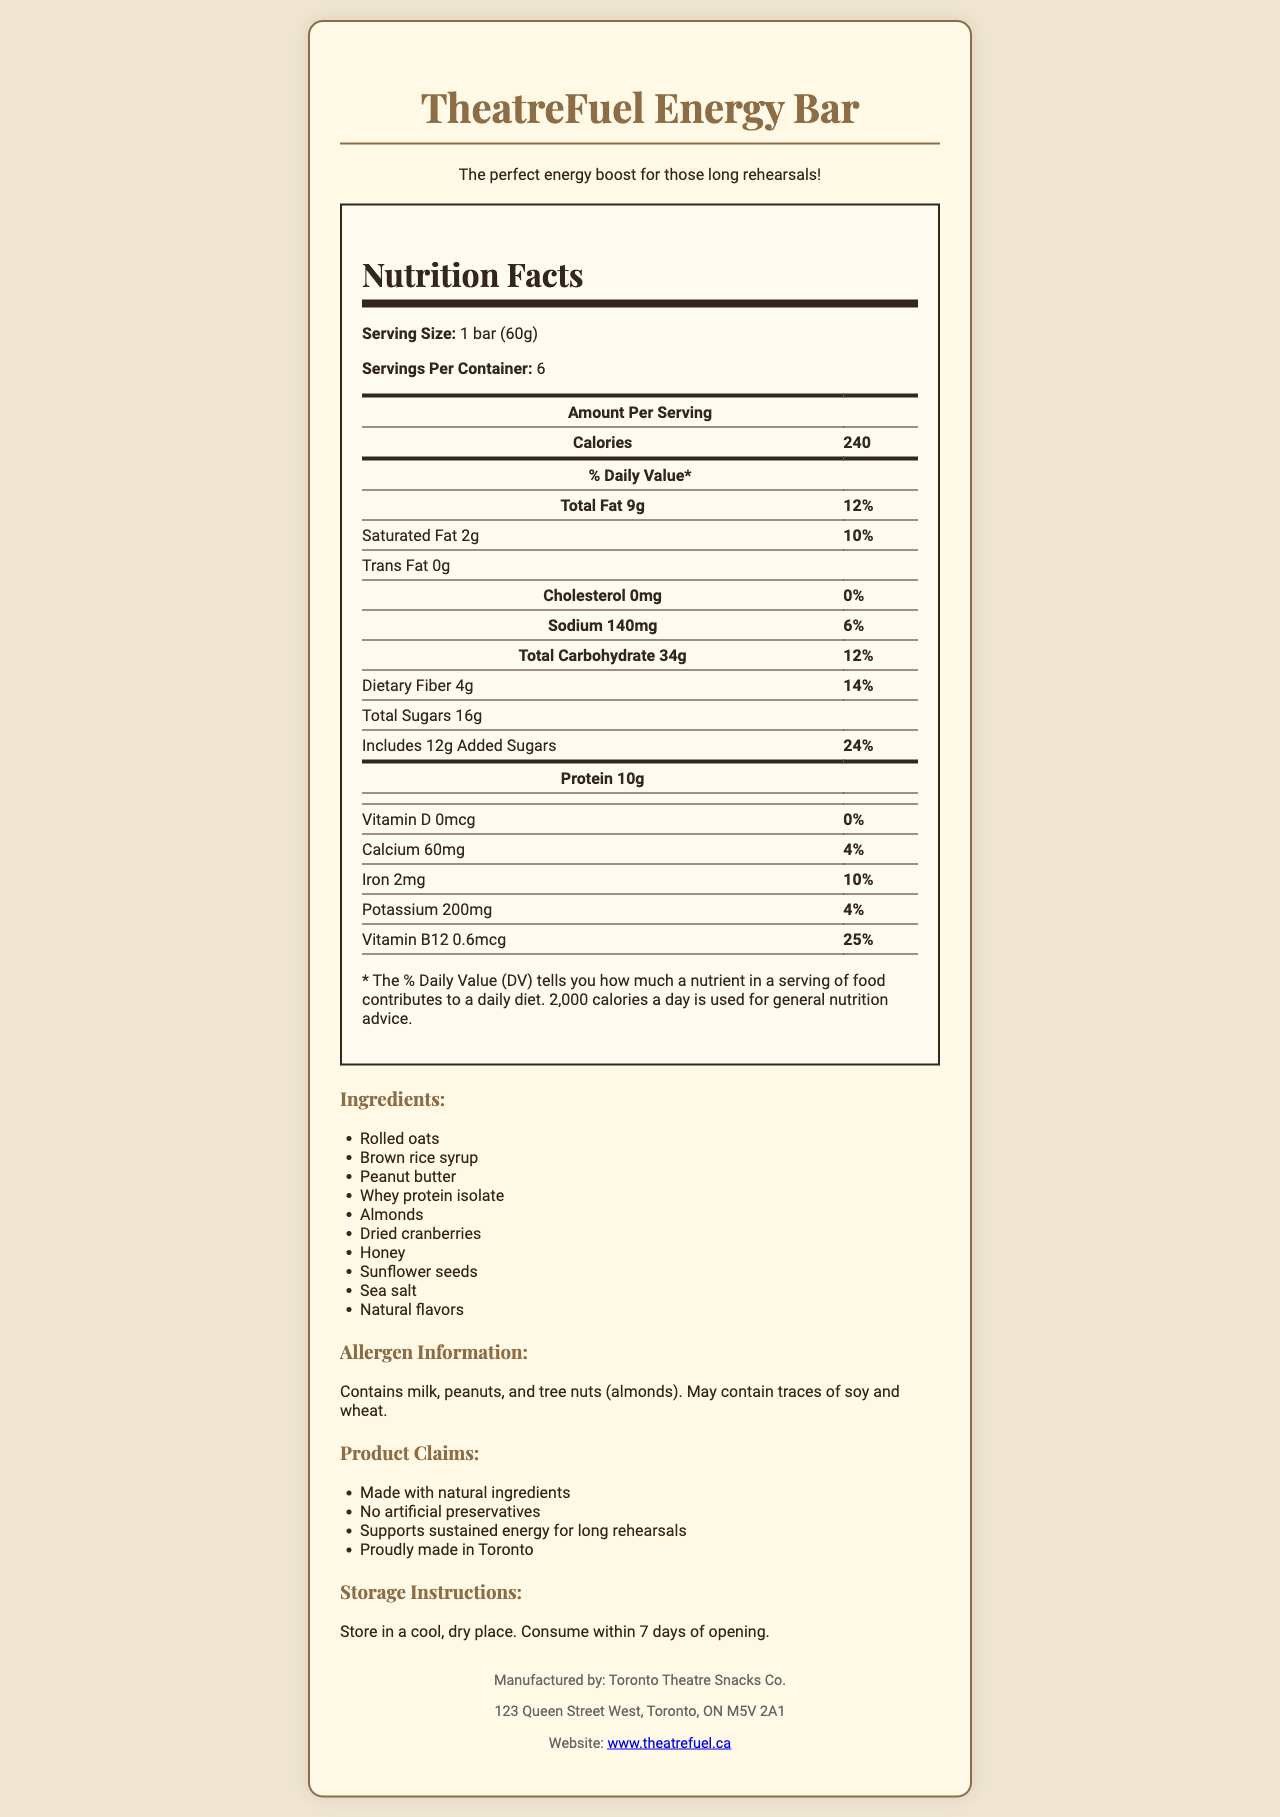what is the serving size of TheatreFuel Energy Bar? The serving size is clearly mentioned below the product name in the nutrition facts section as "1 bar (60g)".
Answer: 1 bar (60g) how many servings are in one container? The document states that there are 6 servings per container.
Answer: 6 how many calories are there per serving? The calories per serving are listed in the "Amount Per Serving" section as 240.
Answer: 240 what is the total fat content and its percentage of daily value? The "Total Fat" content is detailed with its amount as 9g and its daily value percentage as 12%.
Answer: 9g, 12% how much protein does each bar contain? The protein content per serving is listed as 10g.
Answer: 10g which ingredient might cause allergies? A. Rolled oats B. Peanut butter C. Sunflower seeds D. Honey The allergen information indicates that the product contains milk, peanuts (from peanut butter), and tree nuts.
Answer: B how should this product be stored for best results? The storage instructions indicate to store the product in a cool, dry place and to consume it within 7 days of opening.
Answer: Store in a cool, dry place. Consume within 7 days of opening. does the TheatreFuel Energy Bar contain any artificial preservatives? One of the product claims explicitly states "No artificial preservatives".
Answer: No how much dietary fiber is in one serving, and what percentage of the daily value does it provide? The dietary fiber content is 4g per serving, and it provides 14% of the daily value.
Answer: 4g, 14% how can you contact the manufacturer of TheatreFuel Energy Bar? The address of the manufacturer, Toronto Theatre Snacks Co., is provided at the bottom of the document.
Answer: 123 Queen Street West, Toronto, ON M5V 2A1 how much vitamin B12 is there per serving, and what percentage of the daily value does it provide? Vitamin B12 content per serving is 0.6mcg and it provides 25% of the daily value.
Answer: 0.6mcg, 25% are there any trans fats in this energy bar? The nutrition facts state that there is 0g of trans fat in the product.
Answer: No which of the following is a claim made about this product? A. Gluten-free B. Organic C. Supports sustained energy D. Low sodium Among the product claims, one claim is "Supports sustained energy for long rehearsals."
Answer: C what is the main idea of this document? The document comprehensively describe the nutritional facts, ingredients, allergen information, and claims about the TheatreFuel Energy Bar, intended to inform consumers about its contents and benefits.
Answer: The document provides detailed nutritional information about the TheatreFuel Energy Bar, including serving size, ingredients, allergen information, and storage instructions, along with claims about its benefits and manufacturing details. what is the fiber content of the product? A. 2g B. 4g C. 6g D. 8g The dietary fiber content is listed as 4g per serving, making the correct answer B.
Answer: B does this product provide any vitamin D? The document lists vitamin D as 0mcg per serving with a daily value of 0%.
Answer: No are there any allergens listed in this product? If yes, which ones? The allergen information section lists milk, peanuts, and tree nuts (almonds).
Answer: Yes, milk, peanuts, and tree nuts (almonds). what type of fat is not present in the TheatreFuel Energy Bar? The document indicates that there is 0g of trans fat in the product.
Answer: Trans fat how many grams of added sugars are included per serving? The nutrition facts state that there are 12g of added sugars per serving.
Answer: 12g how long does it take for the product to expire after opening? The storage instructions indicate that the product should be consumed within 7 days of opening.
Answer: 7 days can you tell me the source of the whey protein isolate in the TheatreFuel Energy Bar? The document does not provide details on the source of whey protein isolate used in the bar.
Answer: Not enough information 